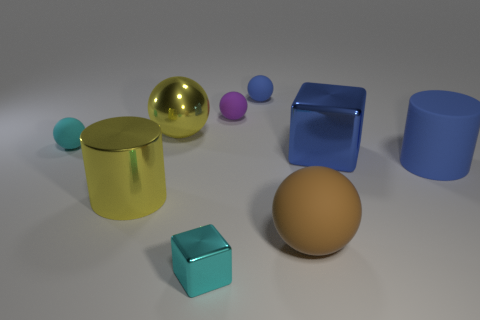What color is the cylinder that is on the right side of the ball that is on the right side of the tiny blue object? The cylinder to the right side of the ball, which in turn is to the right side of the tiny blue object, appears to be green. Specifically, it's a pale shade of green with a metallic finish, adding a sense of shine to its surface. 